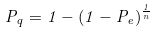<formula> <loc_0><loc_0><loc_500><loc_500>P _ { q } = 1 - ( 1 - P _ { e } ) ^ { \frac { 1 } { n } }</formula> 